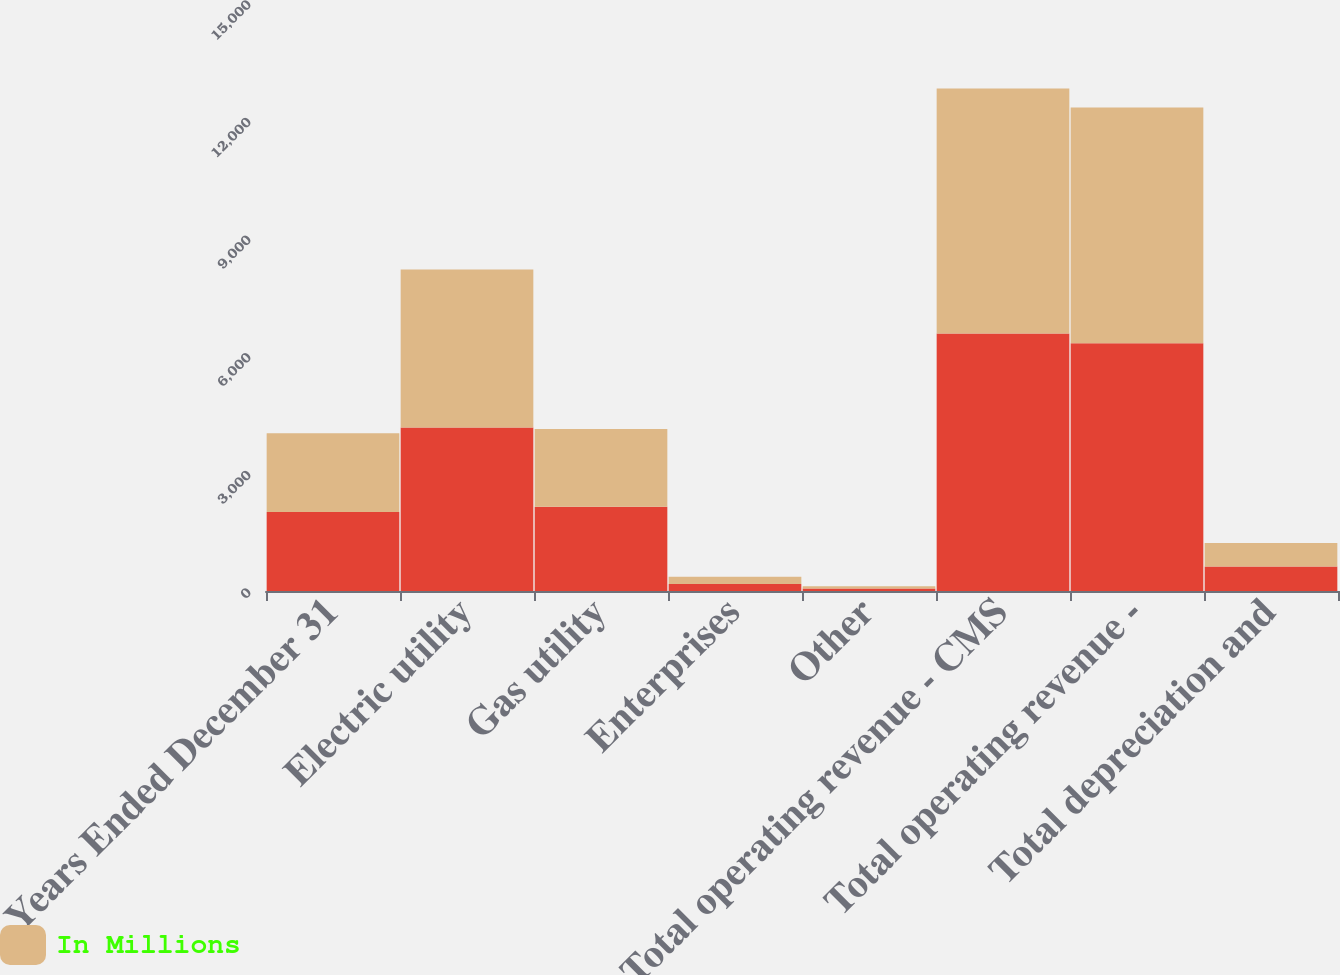Convert chart. <chart><loc_0><loc_0><loc_500><loc_500><stacked_bar_chart><ecel><fcel>Years Ended December 31<fcel>Electric utility<fcel>Gas utility<fcel>Enterprises<fcel>Other<fcel>Total operating revenue - CMS<fcel>Total operating revenue -<fcel>Total depreciation and<nl><fcel>nan<fcel>2013<fcel>4173<fcel>2148<fcel>181<fcel>64<fcel>6566<fcel>6321<fcel>628<nl><fcel>In Millions<fcel>2012<fcel>4031<fcel>1982<fcel>183<fcel>57<fcel>6253<fcel>6013<fcel>598<nl></chart> 